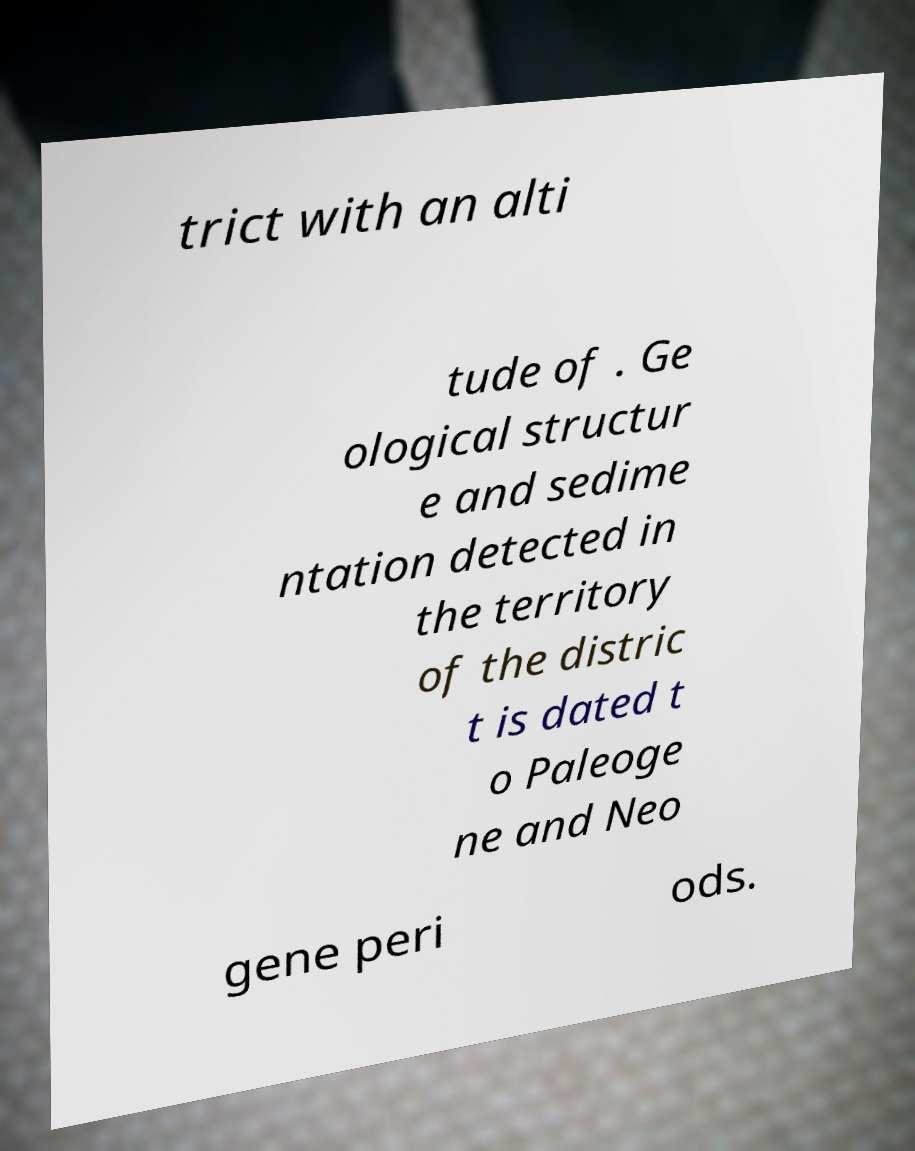Can you accurately transcribe the text from the provided image for me? trict with an alti tude of . Ge ological structur e and sedime ntation detected in the territory of the distric t is dated t o Paleoge ne and Neo gene peri ods. 